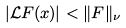Convert formula to latex. <formula><loc_0><loc_0><loc_500><loc_500>\left | \mathcal { L } F ( x ) \right | < \| F \| _ { \nu }</formula> 